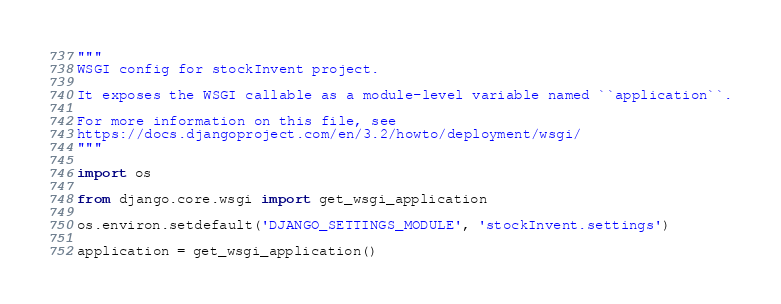<code> <loc_0><loc_0><loc_500><loc_500><_Python_>"""
WSGI config for stockInvent project.

It exposes the WSGI callable as a module-level variable named ``application``.

For more information on this file, see
https://docs.djangoproject.com/en/3.2/howto/deployment/wsgi/
"""

import os

from django.core.wsgi import get_wsgi_application

os.environ.setdefault('DJANGO_SETTINGS_MODULE', 'stockInvent.settings')

application = get_wsgi_application()
</code> 